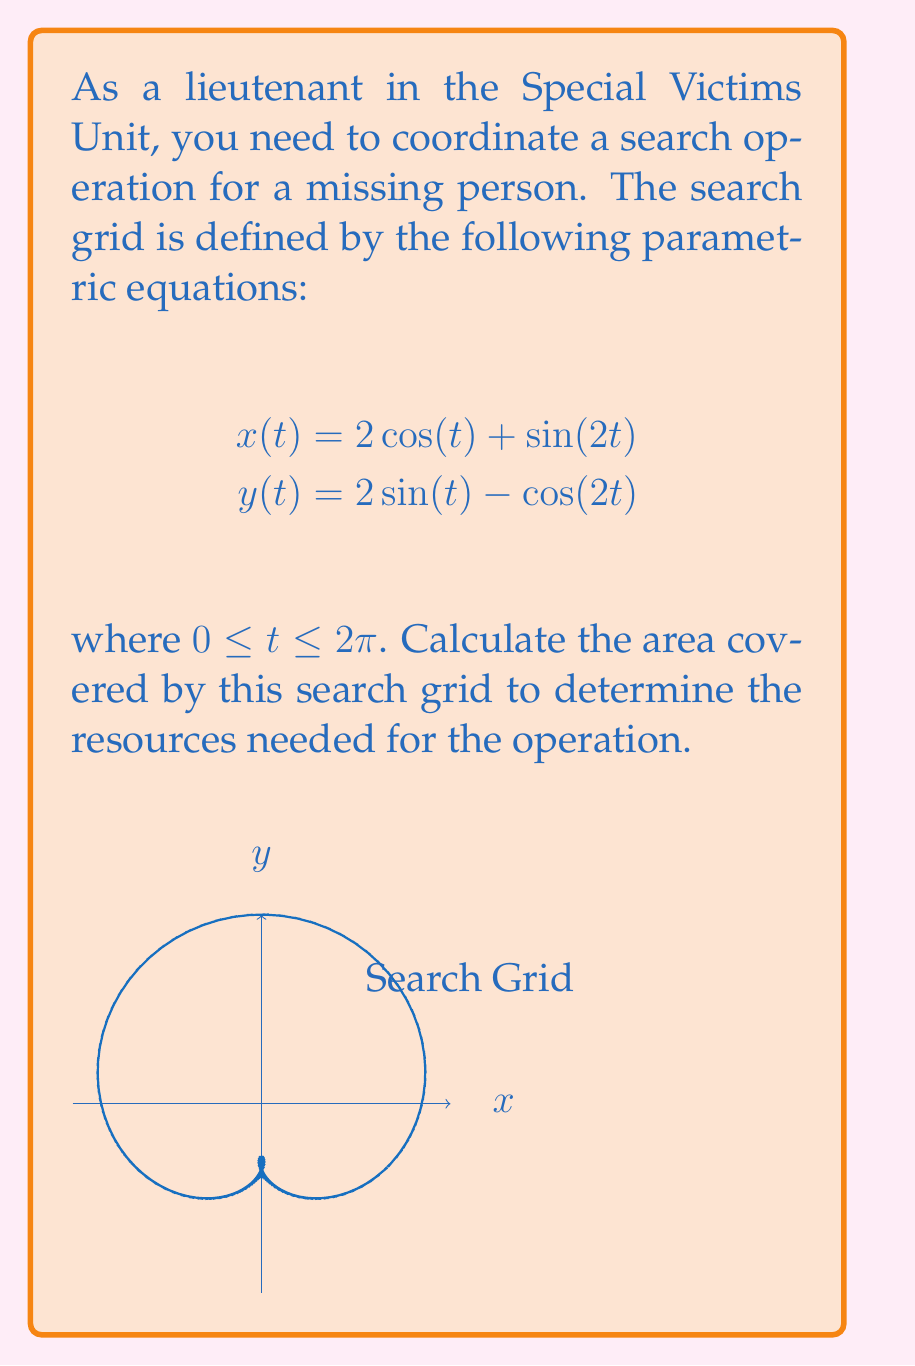Teach me how to tackle this problem. To calculate the area enclosed by a parametric curve, we can use Green's theorem:

$$\text{Area} = \frac{1}{2} \int_0^{2\pi} [x(t)\frac{dy}{dt} - y(t)\frac{dx}{dt}] dt$$

Step 1: Calculate $\frac{dx}{dt}$ and $\frac{dy}{dt}$
$$\frac{dx}{dt} = -2\sin(t) + 2\cos(2t)$$
$$\frac{dy}{dt} = 2\cos(t) + 2\sin(2t)$$

Step 2: Substitute into the area formula
$$\text{Area} = \frac{1}{2} \int_0^{2\pi} [(2\cos(t) + \sin(2t))(2\cos(t) + 2\sin(2t)) - (2\sin(t) - \cos(2t))(-2\sin(t) + 2\cos(2t))] dt$$

Step 3: Expand the integrand
$$\text{Area} = \frac{1}{2} \int_0^{2\pi} [4\cos^2(t) + 4\cos(t)\sin(2t) + 2\sin(2t)\cos(t) + 2\sin^2(2t) + 4\sin^2(t) - 4\sin(t)\cos(2t) - 2\cos(2t)\sin(t) + 2\cos^2(2t)] dt$$

Step 4: Simplify using trigonometric identities
$$\text{Area} = \frac{1}{2} \int_0^{2\pi} [4\cos^2(t) + 6\cos(t)\sin(2t) + 4\sin^2(t) - 6\sin(t)\cos(2t) + 2\sin^2(2t) + 2\cos^2(2t)] dt$$
$$\text{Area} = \frac{1}{2} \int_0^{2\pi} [4 + 6\cos(t)\sin(2t) - 6\sin(t)\cos(2t) + 2] dt$$
$$\text{Area} = \frac{1}{2} \int_0^{2\pi} [6 + 6(\cos(t)\sin(2t) - \sin(t)\cos(2t))] dt$$

Step 5: Use the trigonometric identity $\sin(a-b) = \sin(a)\cos(b) - \cos(a)\sin(b)$
$$\text{Area} = \frac{1}{2} \int_0^{2\pi} [6 - 6\sin(t-2t)] dt = \frac{1}{2} \int_0^{2\pi} [6 + 6\sin(t)] dt$$

Step 6: Integrate
$$\text{Area} = \frac{1}{2} [6t - 6\cos(t)]_0^{2\pi} = \frac{1}{2} [12\pi - 6\cos(2\pi) + 6\cos(0)] = 6\pi$$

Therefore, the area covered by the search grid is $6\pi$ square units.
Answer: $6\pi$ square units 